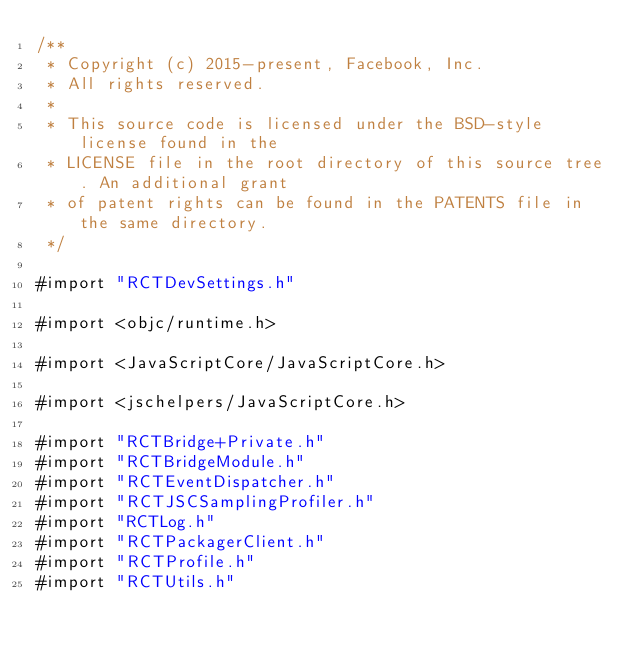Convert code to text. <code><loc_0><loc_0><loc_500><loc_500><_ObjectiveC_>/**
 * Copyright (c) 2015-present, Facebook, Inc.
 * All rights reserved.
 *
 * This source code is licensed under the BSD-style license found in the
 * LICENSE file in the root directory of this source tree. An additional grant
 * of patent rights can be found in the PATENTS file in the same directory.
 */

#import "RCTDevSettings.h"

#import <objc/runtime.h>

#import <JavaScriptCore/JavaScriptCore.h>

#import <jschelpers/JavaScriptCore.h>

#import "RCTBridge+Private.h"
#import "RCTBridgeModule.h"
#import "RCTEventDispatcher.h"
#import "RCTJSCSamplingProfiler.h"
#import "RCTLog.h"
#import "RCTPackagerClient.h"
#import "RCTProfile.h"
#import "RCTUtils.h"
</code> 